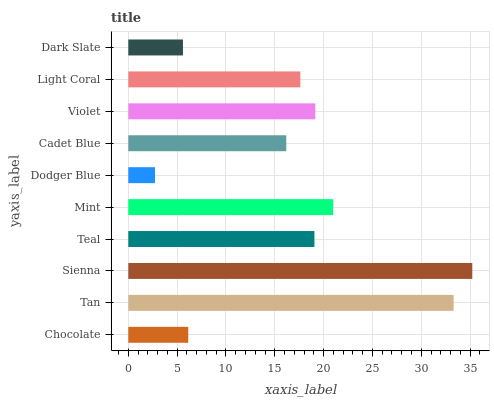Is Dodger Blue the minimum?
Answer yes or no. Yes. Is Sienna the maximum?
Answer yes or no. Yes. Is Tan the minimum?
Answer yes or no. No. Is Tan the maximum?
Answer yes or no. No. Is Tan greater than Chocolate?
Answer yes or no. Yes. Is Chocolate less than Tan?
Answer yes or no. Yes. Is Chocolate greater than Tan?
Answer yes or no. No. Is Tan less than Chocolate?
Answer yes or no. No. Is Teal the high median?
Answer yes or no. Yes. Is Light Coral the low median?
Answer yes or no. Yes. Is Mint the high median?
Answer yes or no. No. Is Chocolate the low median?
Answer yes or no. No. 